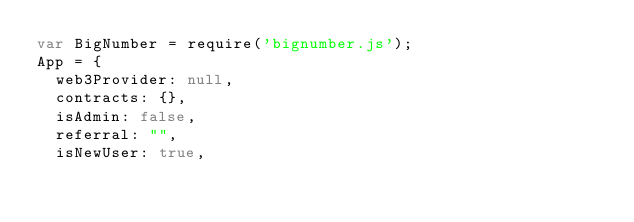<code> <loc_0><loc_0><loc_500><loc_500><_JavaScript_>var BigNumber = require('bignumber.js');
App = {
  web3Provider: null,
  contracts: {},
  isAdmin: false,
  referral: "",
  isNewUser: true,
</code> 